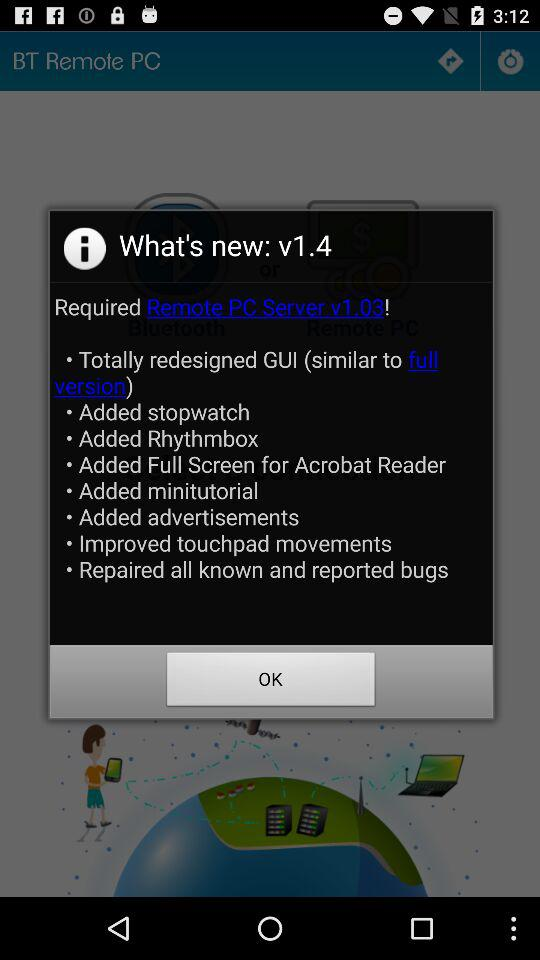What server is required? The required server is "Remote PC Server v1.03!". 